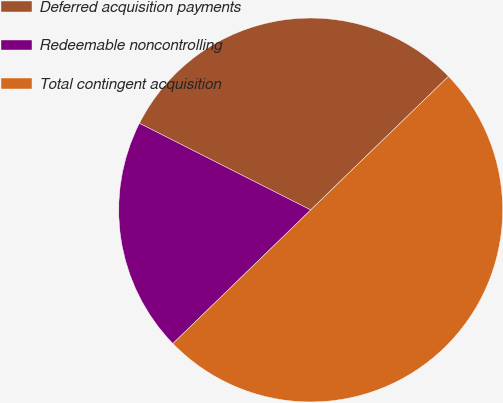Convert chart to OTSL. <chart><loc_0><loc_0><loc_500><loc_500><pie_chart><fcel>Deferred acquisition payments<fcel>Redeemable noncontrolling<fcel>Total contingent acquisition<nl><fcel>30.29%<fcel>19.71%<fcel>50.0%<nl></chart> 